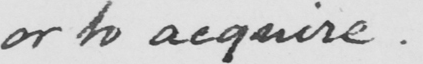Please transcribe the handwritten text in this image. or to acquire . 